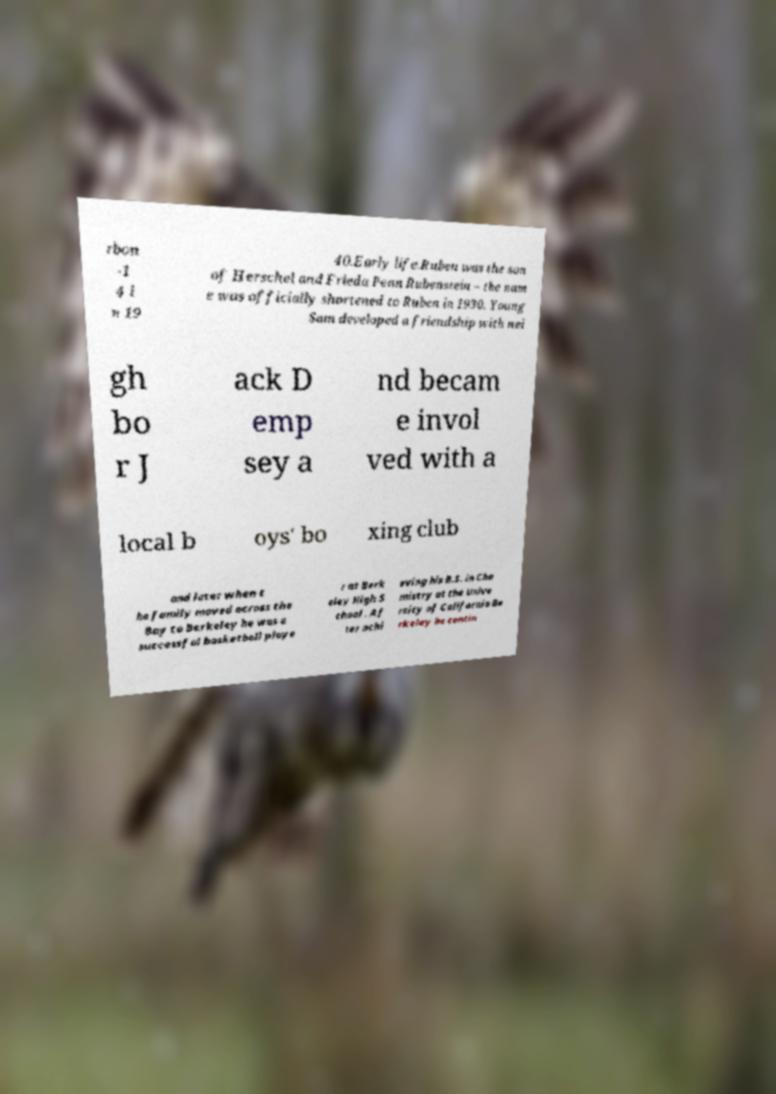Please read and relay the text visible in this image. What does it say? rbon -1 4 i n 19 40.Early life.Ruben was the son of Herschel and Frieda Penn Rubenstein – the nam e was officially shortened to Ruben in 1930. Young Sam developed a friendship with nei gh bo r J ack D emp sey a nd becam e invol ved with a local b oys' bo xing club and later when t he family moved across the Bay to Berkeley he was a successful basketball playe r at Berk eley High S chool . Af ter achi eving his B.S. in Che mistry at the Unive rsity of California Be rkeley he contin 